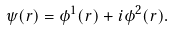Convert formula to latex. <formula><loc_0><loc_0><loc_500><loc_500>\psi ( r ) = \phi ^ { 1 } ( r ) + i \phi ^ { 2 } ( r ) .</formula> 